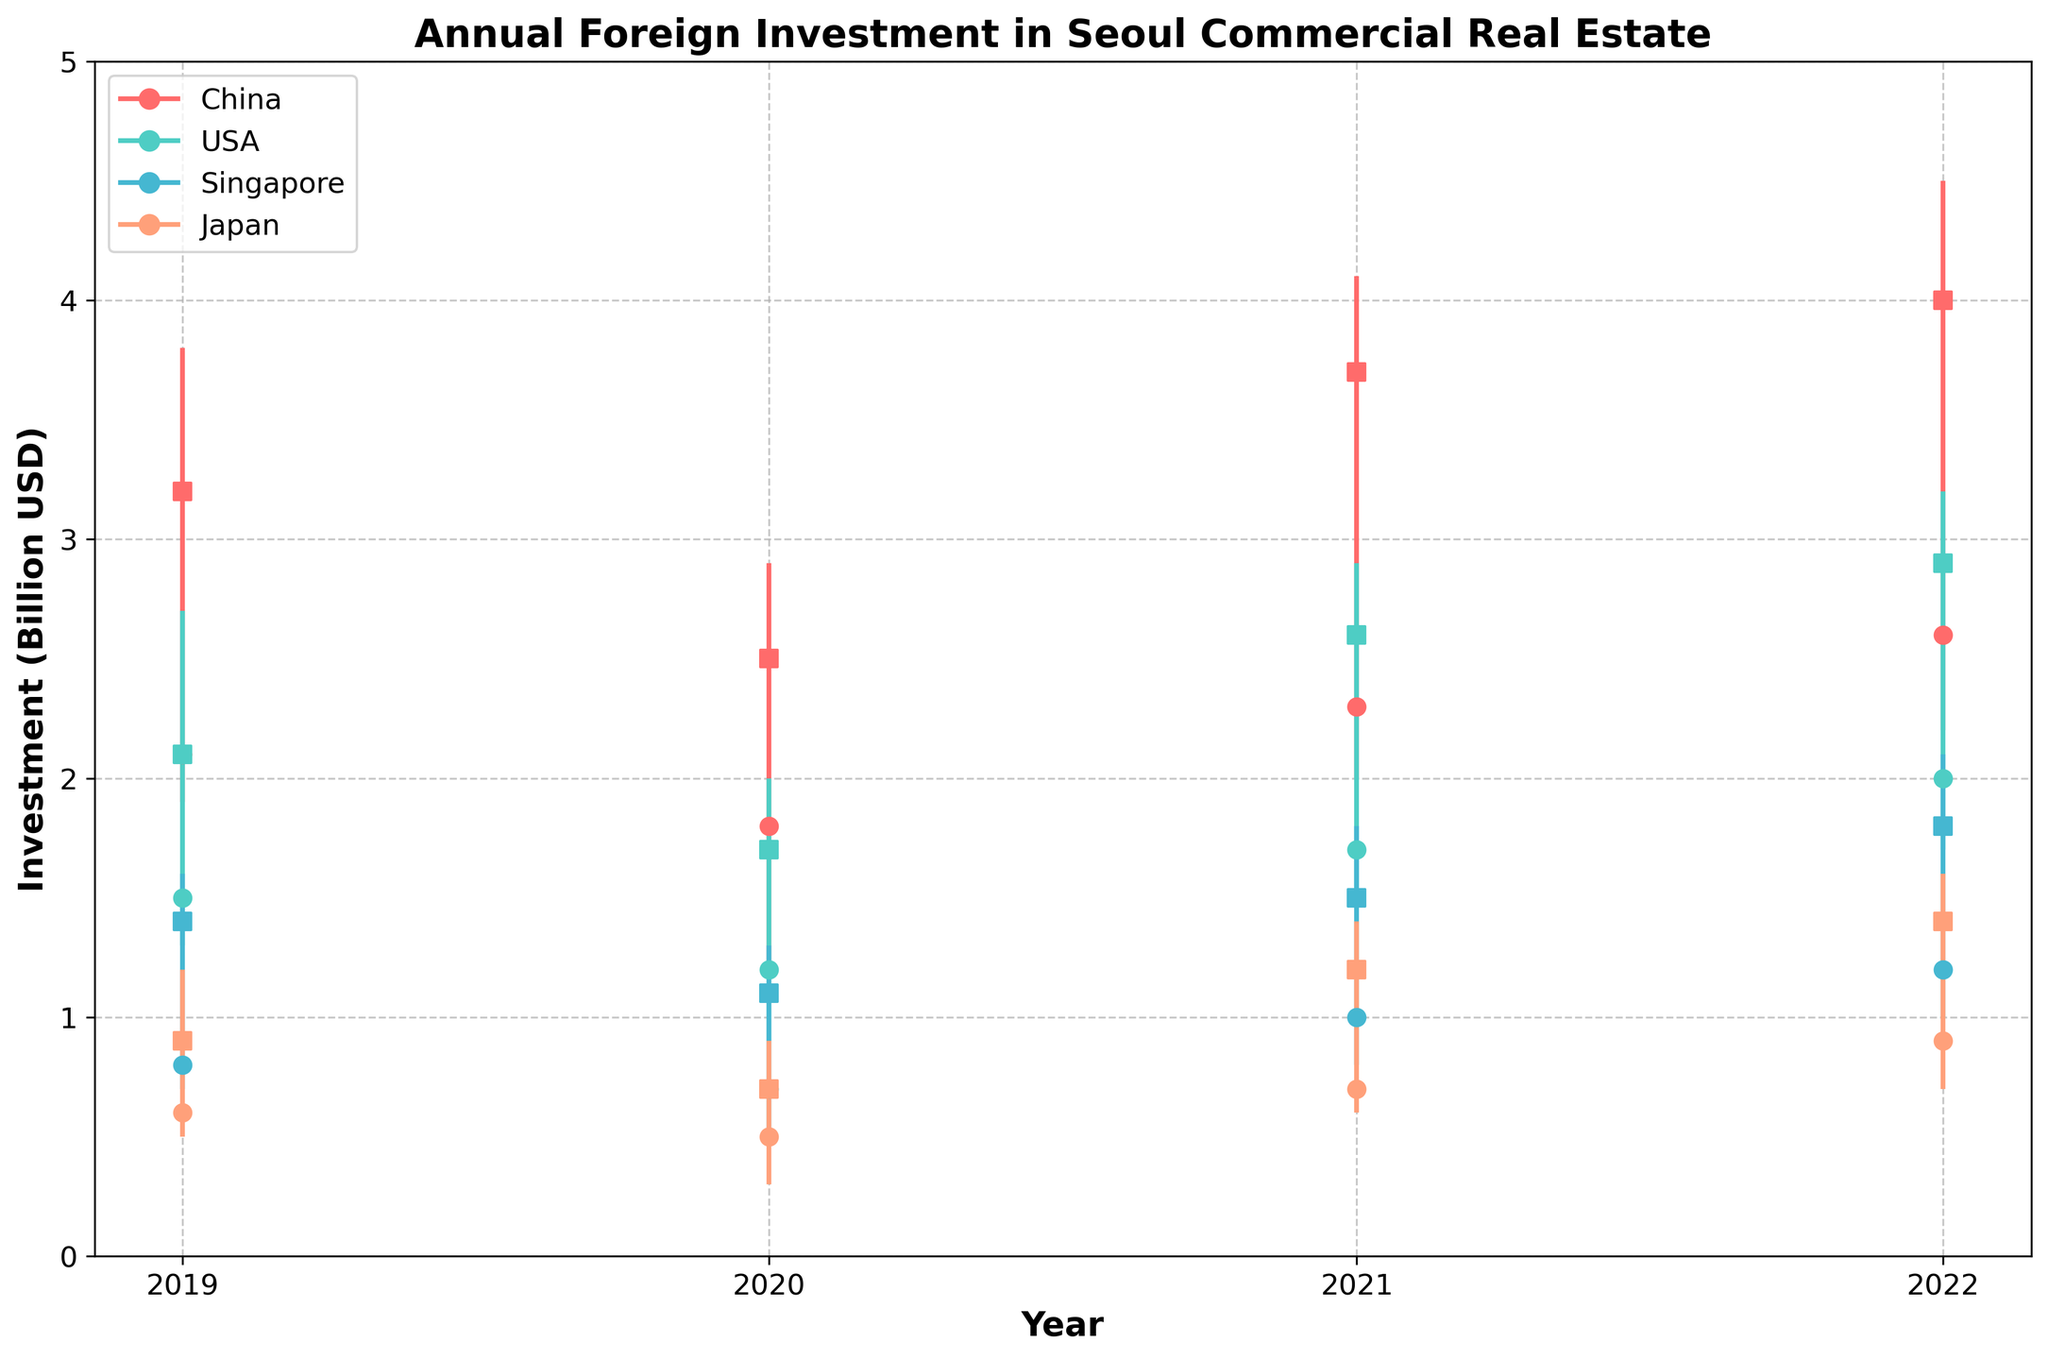What is the title of the chart? The title is usually found at the top of the chart. In this chart, the title is written in bold.
Answer: Annual Foreign Investment in Seoul Commercial Real Estate Which country had the highest investment in 2022? By looking at the lines representing each country for the year 2022, we can observe that China has the highest 'High' value reaching 4.5 billion USD.
Answer: China What is the range of investment for the USA in 2021? The range of investment can be calculated by subtracting the 'Low' value from the 'High' value for the USA in 2021. The values are 2.9 (High) and 1.5 (Low). Thus, the range is 2.9 - 1.5.
Answer: 1.4 billion USD How do China's investment trends in 2020 and 2021 compare? We need to compare the position of the OHLC (Open, High, Low, Close) bars for China in 2020 and 2021. China's investment 'High' increased from 2.9 in 2020 to 4.1 in 2021, and the 'Close' value increased from 2.5 in 2020 to 3.7 in 2021.
Answer: Investment increased Which year had the lowest investment by Japan? By examining the 'Low' points for Japan across all years, we see that the lowest 'Low' value is 0.3 billion USD in 2020.
Answer: 2020 In which year did Singapore see the highest close value? By observing the 'Close' values for Singapore each year, the highest close value is 1.8 billion USD in 2022.
Answer: 2022 What is the average high value for USA investments over the four years? To find the average, sum the 'High' values for the USA for each year (2.7 + 2.0 + 2.9 + 3.2) and then divide by 4. The sum is 10.8, so the average is 10.8 / 4.
Answer: 2.7 billion USD Did any country have a decrease in high investment values from 2020 to 2021? By comparing 'High' values from 2020 and 2021 for each country, we see that Japan's 'High' decreased from 0.9 in 2020 to 1.4 in 2021.
Answer: No Which country had the most volatile investment in 2019, and what's the volatility range? Volatility can be determined by the difference between 'High' and 'Low' values. For 2019, China had the most significant difference (3.8 - 1.9).
Answer: China, 1.9 billion USD How did the open values for Singapore change from 2019 to 2022? We look at the 'Open' values for Singapore from 2019 to 2022 and note them. The values are 0.8, 0.7, 1.0, and 1.2 respectively.
Answer: Increased 